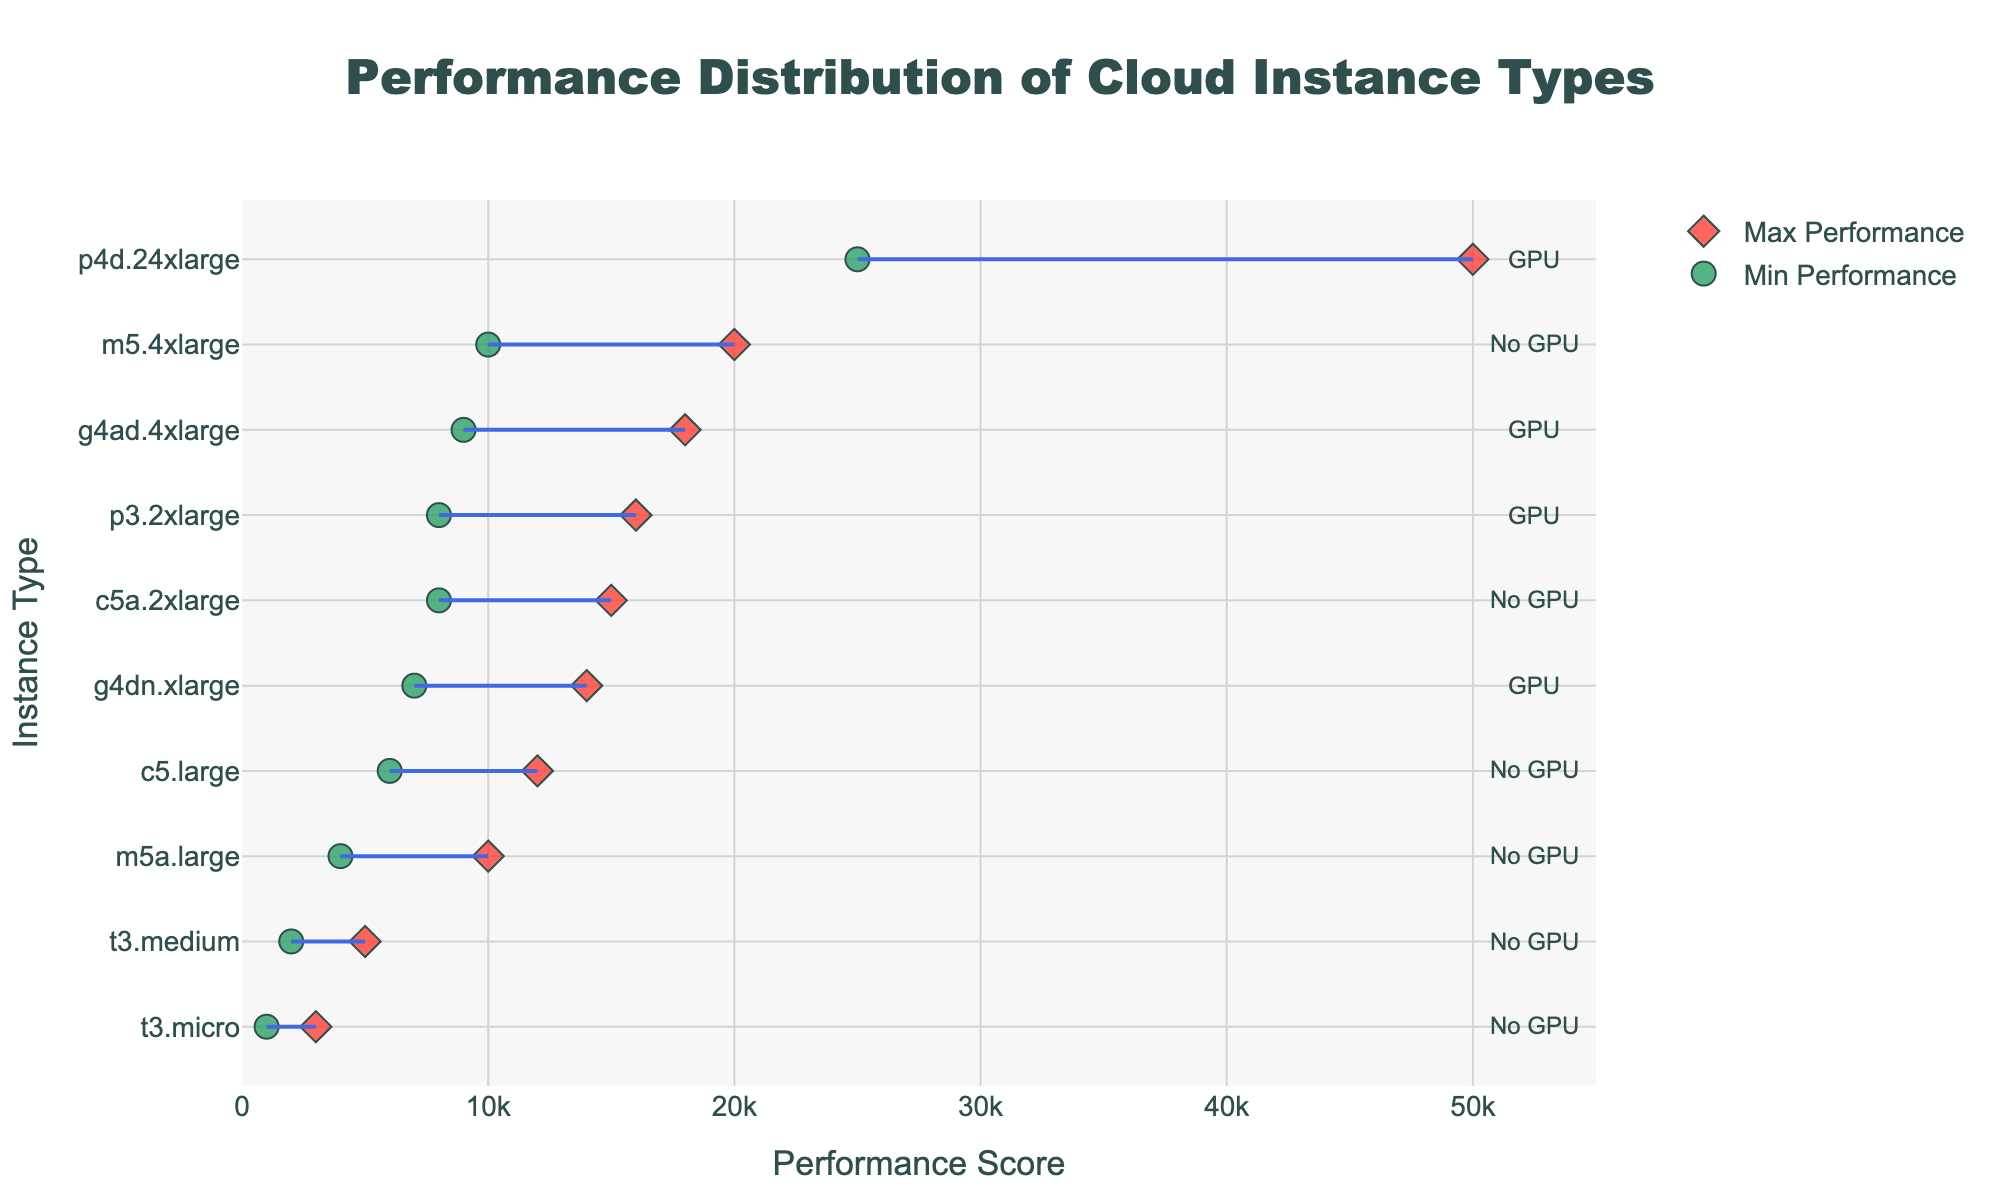What is the title of the figure? The title can be found at the top of the figure, typically centered and prominent. The title for this figure is provided in the data.
Answer: Performance Distribution of Cloud Instance Types What are the x-axis and y-axis labels? The x-axis label is usually found beneath the x-axis, and the y-axis label is found next to the y-axis. In this figure, they describe the context of the plotted data.
Answer: The x-axis is labeled "Performance Score" and the y-axis is labeled "Instance Type." How many instance types are included in the plot? Each instance type corresponds to a unique value on the y-axis. By counting the number of unique instance types listed, we can determine the total number.
Answer: 10 Which instance type in the us-east-2 region has the highest max performance? By locating the region us-east-2 on y-axis and then checking its corresponding maximum performance on the x-axis, we can deduce the instance type. Only one instance falls under this criteria.
Answer: p4d.24xlarge Which regions have instance types with GPU capabilities? The GPU information is annotated beside each instance type on the y-axis. We look for instances with "GPU" labels and trace them to their regions.
Answer: us-east-1, eu-west-1, eu-north-1, us-east-2 What is the minimum performance score for the t3.micro instance type? Locate the t3.micro instance type on the y-axis and find its corresponding minimum performance on the x-axis. The minimum values are represented by circles.
Answer: 1000 Which instance type has the widest performance range, and what is the range? Calculate the range by subtracting the minimum performance from the maximum performance for each instance type. The instance type with the highest difference has the widest range.
Answer: p4d.24xlarge, with a range of 25000 Compare the maximum performance scores of m5.4xlarge and c5a.2xlarge instances. Which one is higher? Locate both instance types on the y-axis, then compare their corresponding maximum performance scores on the x-axis.
Answer: m5.4xlarge has a higher max performance of 20000, whereas c5a.2xlarge has 15000 What are the performance ranges for GPU-enabled instance types in eu-west-1 and us-east-1 regions? Identify GPU-enabled instance types in the specified regions, then calculate their ranges by subtracting minimum performance scores from maximum performance scores for each.
Answer: The range for the g4dn.xlarge (eu-west-1) is 7000, and for p3.2xlarge (us-east-1) is 8000 Which instance type has the smallest minimum performance score, and in which region is it located? Scan the data to find the smallest minimum performance value and trace it to its instance type and region.
Answer: t3.micro in sa-east-1 